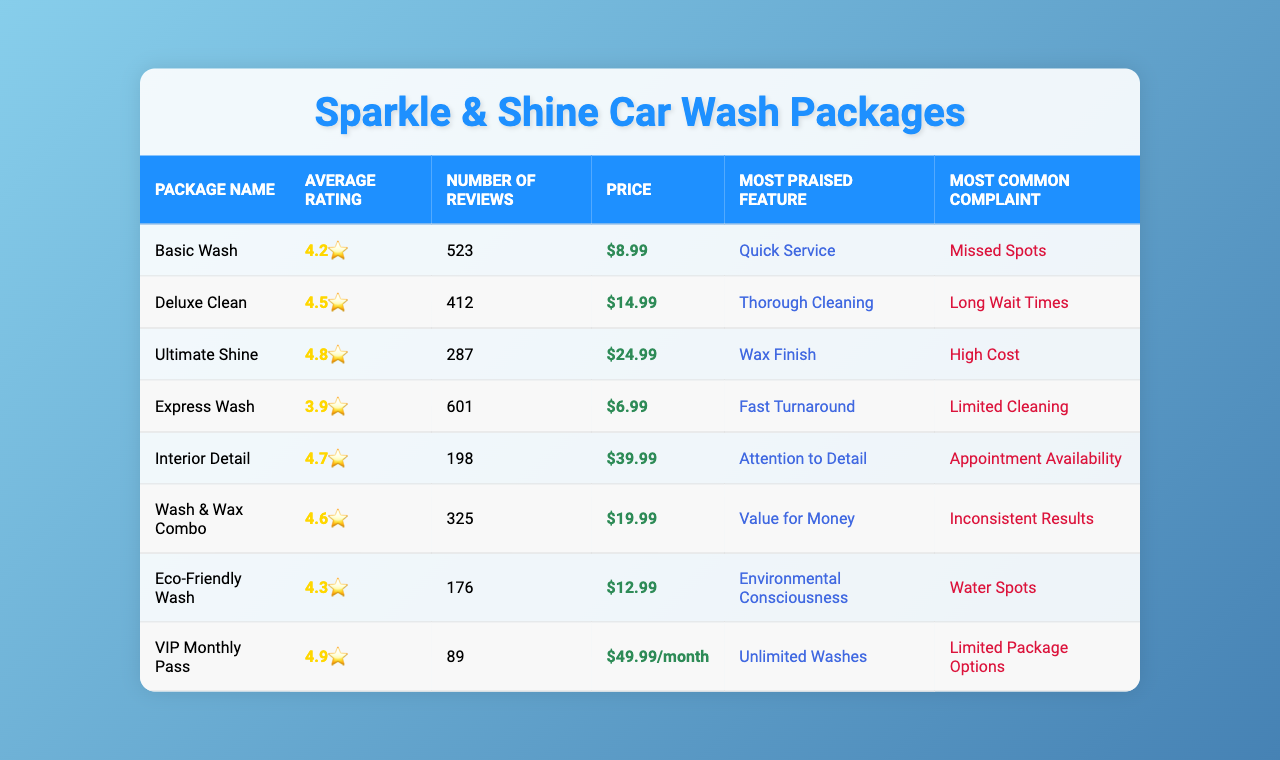What is the average rating of the Basic Wash package? The Basic Wash package has an average rating of 4.2, as listed in the "Average Rating" column.
Answer: 4.2 How many reviews did the Ultimate Shine package receive? The Ultimate Shine package received 287 reviews, which can be found in the "Number of Reviews" column.
Answer: 287 Which package has the most number of reviews? The Express Wash package has the highest number of reviews at 601, seen in the "Number of Reviews" column.
Answer: Express Wash What is the price of the Interior Detail package? The price of the Interior Detail package is $39.99, as shown in the "Price" column.
Answer: $39.99 Which package has the highest average rating? The VIP Monthly Pass has the highest average rating of 4.9, as indicated in the "Average Rating" column.
Answer: VIP Monthly Pass What is the average rating of all car wash packages combined? To find the average rating, sum the ratings (4.2 + 4.5 + 4.8 + 3.9 + 4.7 + 4.6 + 4.3 + 4.9) = 36.9. There are 8 packages, so the average is 36.9/8 = 4.6125, which rounds to 4.6.
Answer: 4.6 Is the Eco-Friendly Wash package rated higher than the Basic Wash package? The Eco-Friendly Wash has a rating of 4.3, which is higher than the Basic Wash rating of 4.2. Therefore, it is true.
Answer: Yes What is the most common complaint for the Deluxe Clean package? The most common complaint for the Deluxe Clean package, found in the "Most Common Complaint" column, is "Long Wait Times."
Answer: Long Wait Times Which package offers the quickest service according to customer feedback? The Basic Wash package is noted for "Quick Service" in the "Most Praised Feature" column, indicating that it offers the quickest service.
Answer: Basic Wash What is the total price of the Wash & Wax Combo and the Ultimate Shine packages? The price of Wash & Wax Combo is $19.99 and Ultimate Shine is $24.99. Adding these gives $19.99 + $24.99 = $44.98.
Answer: $44.98 